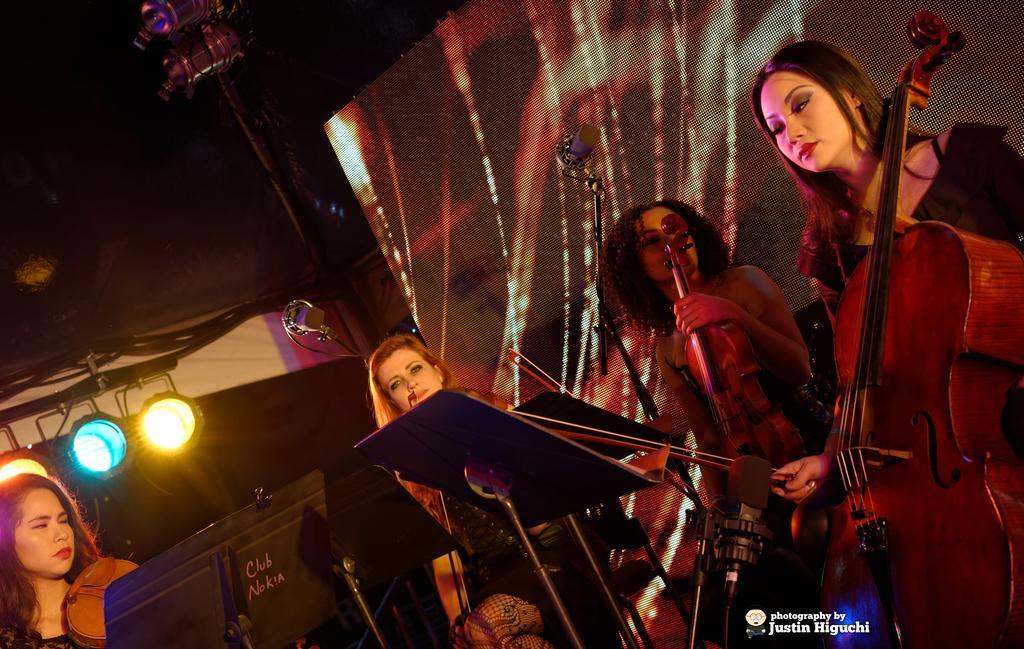Can you describe this image briefly? There is a group of people. They are playing a musical instruments. 